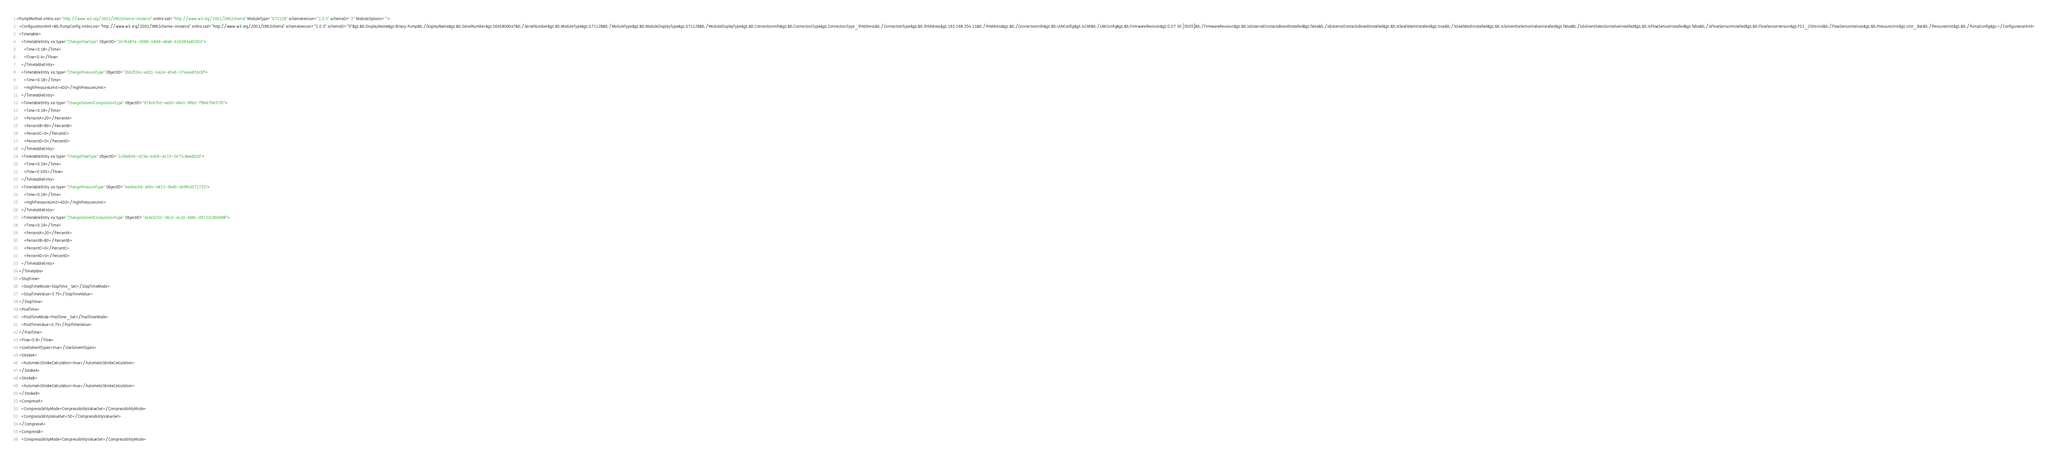Convert code to text. <code><loc_0><loc_0><loc_500><loc_500><_XML_><PumpMethod xmlns:xsi="http://www.w3.org/2001/XMLSchema-instance" xmlns:xsd="http://www.w3.org/2001/XMLSchema" ModuleType="G7112B" schemaVersion="1.0.5" schemaSI="2" ModuleOptions="">
  <ConfigurationXml>&lt;PumpConfig xmlns:xsi="http://www.w3.org/2001/XMLSchema-instance" xmlns:xsd="http://www.w3.org/2001/XMLSchema" schemaVersion="1.0.3" schemaSI="0"&gt;&lt;DisplayName&gt;Binary Pump&lt;/DisplayName&gt;&lt;SerialNumber&gt;DEAE800647&lt;/SerialNumber&gt;&lt;ModuleType&gt;G7112B&lt;/ModuleType&gt;&lt;ModuleDisplayType&gt;G7112B&lt;/ModuleDisplayType&gt;&lt;ConnectionInfo&gt;&lt;ConnectionType&gt;ConnectionType_IPAddress&lt;/ConnectionType&gt;&lt;IPAddress&gt;192.168.254.11&lt;/IPAddress&gt;&lt;/ConnectionInfo&gt;&lt;LANConfig&gt;IsCAP&lt;/LANConfig&gt;&lt;FirmwareRevision&gt;D.07.30 [0005]&lt;/FirmwareRevision&gt;&lt;IsExternalContactsBoardInstalled&gt;false&lt;/IsExternalContactsBoardInstalled&gt;&lt;IsSealWashInstalled&gt;true&lt;/IsSealWashInstalled&gt;&lt;IsSolventSelectionValveInstalled&gt;false&lt;/IsSolventSelectionValveInstalled&gt;&lt;IsFlowSensorInstalled&gt;false&lt;/IsFlowSensorInstalled&gt;&lt;FlowSensorVersion&gt;FS1_20microl&lt;/FlowSensorVersion&gt;&lt;PressureUnit&gt;Unit_Bar&lt;/PressureUnit&gt;&lt;/PumpConfig&gt;</ConfigurationXml>
  <Timetable>
    <TimetableEntry xsi:type="ChangeFlowType" ObjectID="2a76487a-d568-48d9-a8a6-b16583a60003">
      <Time>0.18</Time>
      <Flow>0.4</Flow>
    </TimetableEntry>
    <TimetableEntry xsi:type="ChangePressureType" ObjectID="2bb2f24c-ed21-4a2e-a546-27ecae853cbf">
      <Time>0.18</Time>
      <HighPressureLimit>400</HighPressureLimit>
    </TimetableEntry>
    <TimetableEntry xsi:type="ChangeSolventCompositionType" ObjectID="97bc67bd-eab0-46e0-8f6d-7f84b7bb57f0">
      <Time>0.18</Time>
      <PercentA>20</PercentA>
      <PercentB>80</PercentB>
      <PercentC>0</PercentC>
      <PercentD>0</PercentD>
    </TimetableEntry>
    <TimetableEntry xsi:type="ChangeFlowType" ObjectID="1c0beb04-d15a-4d26-a213-0471c8ee6b50">
      <Time>0.19</Time>
      <Flow>0.035</Flow>
    </TimetableEntry>
    <TimetableEntry xsi:type="ChangePressureType" ObjectID="4a49ec56-efd4-4813-9ad0-ab9f43571731">
      <Time>0.19</Time>
      <HighPressureLimit>400</HighPressureLimit>
    </TimetableEntry>
    <TimetableEntry xsi:type="ChangeSolventCompositionType" ObjectID="3ede3252-36c2-4c2d-b68c-d9722c0bb688">
      <Time>0.19</Time>
      <PercentA>20</PercentA>
      <PercentB>80</PercentB>
      <PercentC>0</PercentC>
      <PercentD>0</PercentD>
    </TimetableEntry>
  </Timetable>
  <StopTime>
    <StopTimeMode>StopTime_Set</StopTimeMode>
    <StopTimeValue>3.75</StopTimeValue>
  </StopTime>
  <PostTime>
    <PostTimeMode>PostTime_Set</PostTimeMode>
    <PostTimeValue>0.75</PostTimeValue>
  </PostTime>
  <Flow>0.8</Flow>
  <UseSolventTypes>true</UseSolventTypes>
  <StrokeA>
    <AutomaticStrokeCalculation>true</AutomaticStrokeCalculation>
  </StrokeA>
  <StrokeB>
    <AutomaticStrokeCalculation>true</AutomaticStrokeCalculation>
  </StrokeB>
  <CompressA>
    <CompressibilityMode>CompressibilityValueSet</CompressibilityMode>
    <CompressibilityValueSet>50</CompressibilityValueSet>
  </CompressA>
  <CompressB>
    <CompressibilityMode>CompressibilityValueSet</CompressibilityMode></code> 